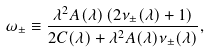<formula> <loc_0><loc_0><loc_500><loc_500>\omega _ { \pm } \equiv \frac { \lambda ^ { 2 } A ( \lambda ) \left ( 2 \nu _ { \pm } ( \lambda ) + 1 \right ) } { 2 C ( \lambda ) + \lambda ^ { 2 } A ( \lambda ) \nu _ { \pm } ( \lambda ) } ,</formula> 